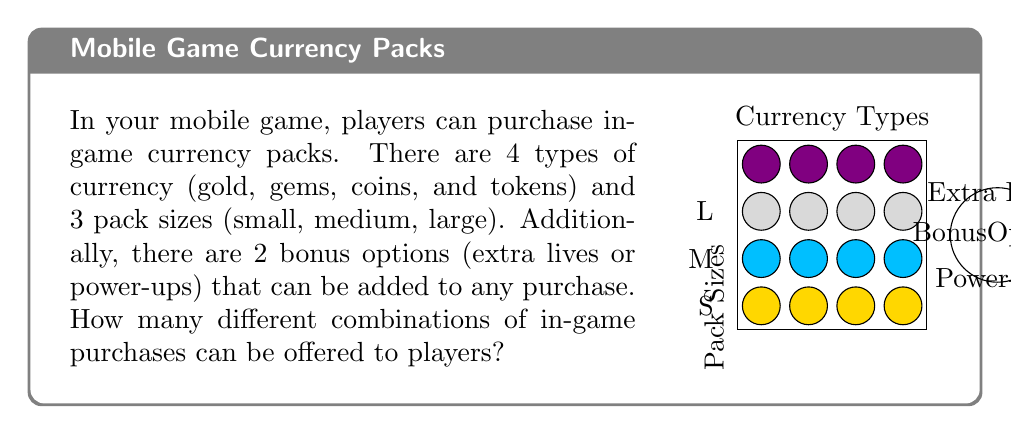Solve this math problem. Let's break this down step-by-step:

1) First, we need to calculate the number of combinations for the currency types and pack sizes:
   - There are 4 currency types
   - There are 3 pack sizes
   - Each currency type can be combined with each pack size
   
   So, the number of combinations here is:
   $$ 4 \times 3 = 12 $$

2) Now, for each of these 12 combinations, we have three options:
   - No bonus
   - Extra lives bonus
   - Power-ups bonus

   This means we need to multiply our previous result by 3:
   $$ 12 \times 3 = 36 $$

3) We can verify this using the multiplication principle of combinatorics:
   $$ \text{Total combinations} = \text{Currency types} \times \text{Pack sizes} \times \text{Bonus options} $$
   $$ = 4 \times 3 \times 3 = 36 $$

Therefore, there are 36 different combinations of in-game purchases that can be offered to players.
Answer: 36 